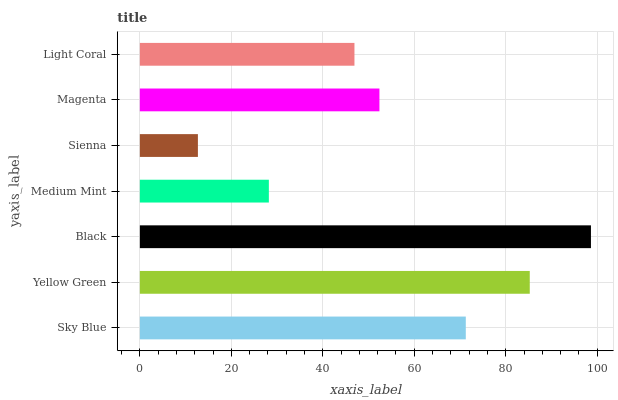Is Sienna the minimum?
Answer yes or no. Yes. Is Black the maximum?
Answer yes or no. Yes. Is Yellow Green the minimum?
Answer yes or no. No. Is Yellow Green the maximum?
Answer yes or no. No. Is Yellow Green greater than Sky Blue?
Answer yes or no. Yes. Is Sky Blue less than Yellow Green?
Answer yes or no. Yes. Is Sky Blue greater than Yellow Green?
Answer yes or no. No. Is Yellow Green less than Sky Blue?
Answer yes or no. No. Is Magenta the high median?
Answer yes or no. Yes. Is Magenta the low median?
Answer yes or no. Yes. Is Black the high median?
Answer yes or no. No. Is Medium Mint the low median?
Answer yes or no. No. 